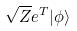Convert formula to latex. <formula><loc_0><loc_0><loc_500><loc_500>\sqrt { Z } e ^ { T } | \phi \rangle</formula> 